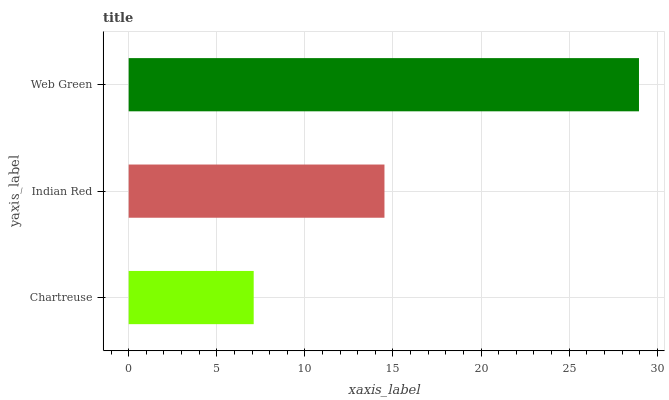Is Chartreuse the minimum?
Answer yes or no. Yes. Is Web Green the maximum?
Answer yes or no. Yes. Is Indian Red the minimum?
Answer yes or no. No. Is Indian Red the maximum?
Answer yes or no. No. Is Indian Red greater than Chartreuse?
Answer yes or no. Yes. Is Chartreuse less than Indian Red?
Answer yes or no. Yes. Is Chartreuse greater than Indian Red?
Answer yes or no. No. Is Indian Red less than Chartreuse?
Answer yes or no. No. Is Indian Red the high median?
Answer yes or no. Yes. Is Indian Red the low median?
Answer yes or no. Yes. Is Web Green the high median?
Answer yes or no. No. Is Web Green the low median?
Answer yes or no. No. 